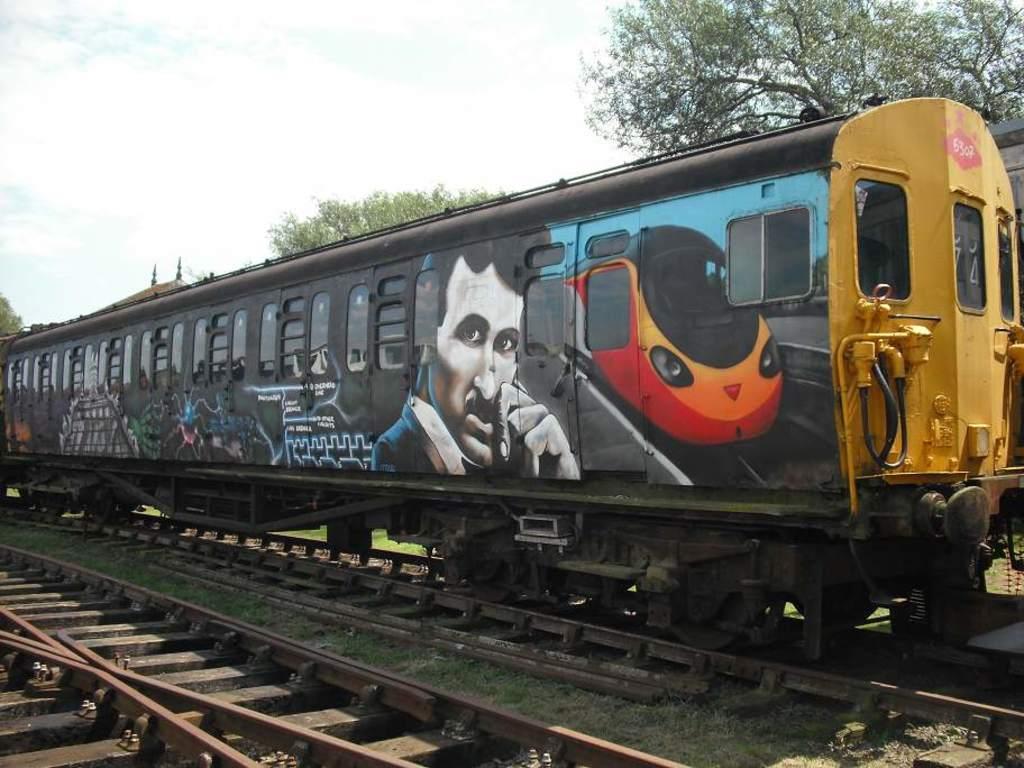Could you give a brief overview of what you see in this image? In this picture we can observe a train on the railway track. Beside this train there is another track. The train is in black color. We can observe a person's picture on the train. In the background there are trees and a sky. 